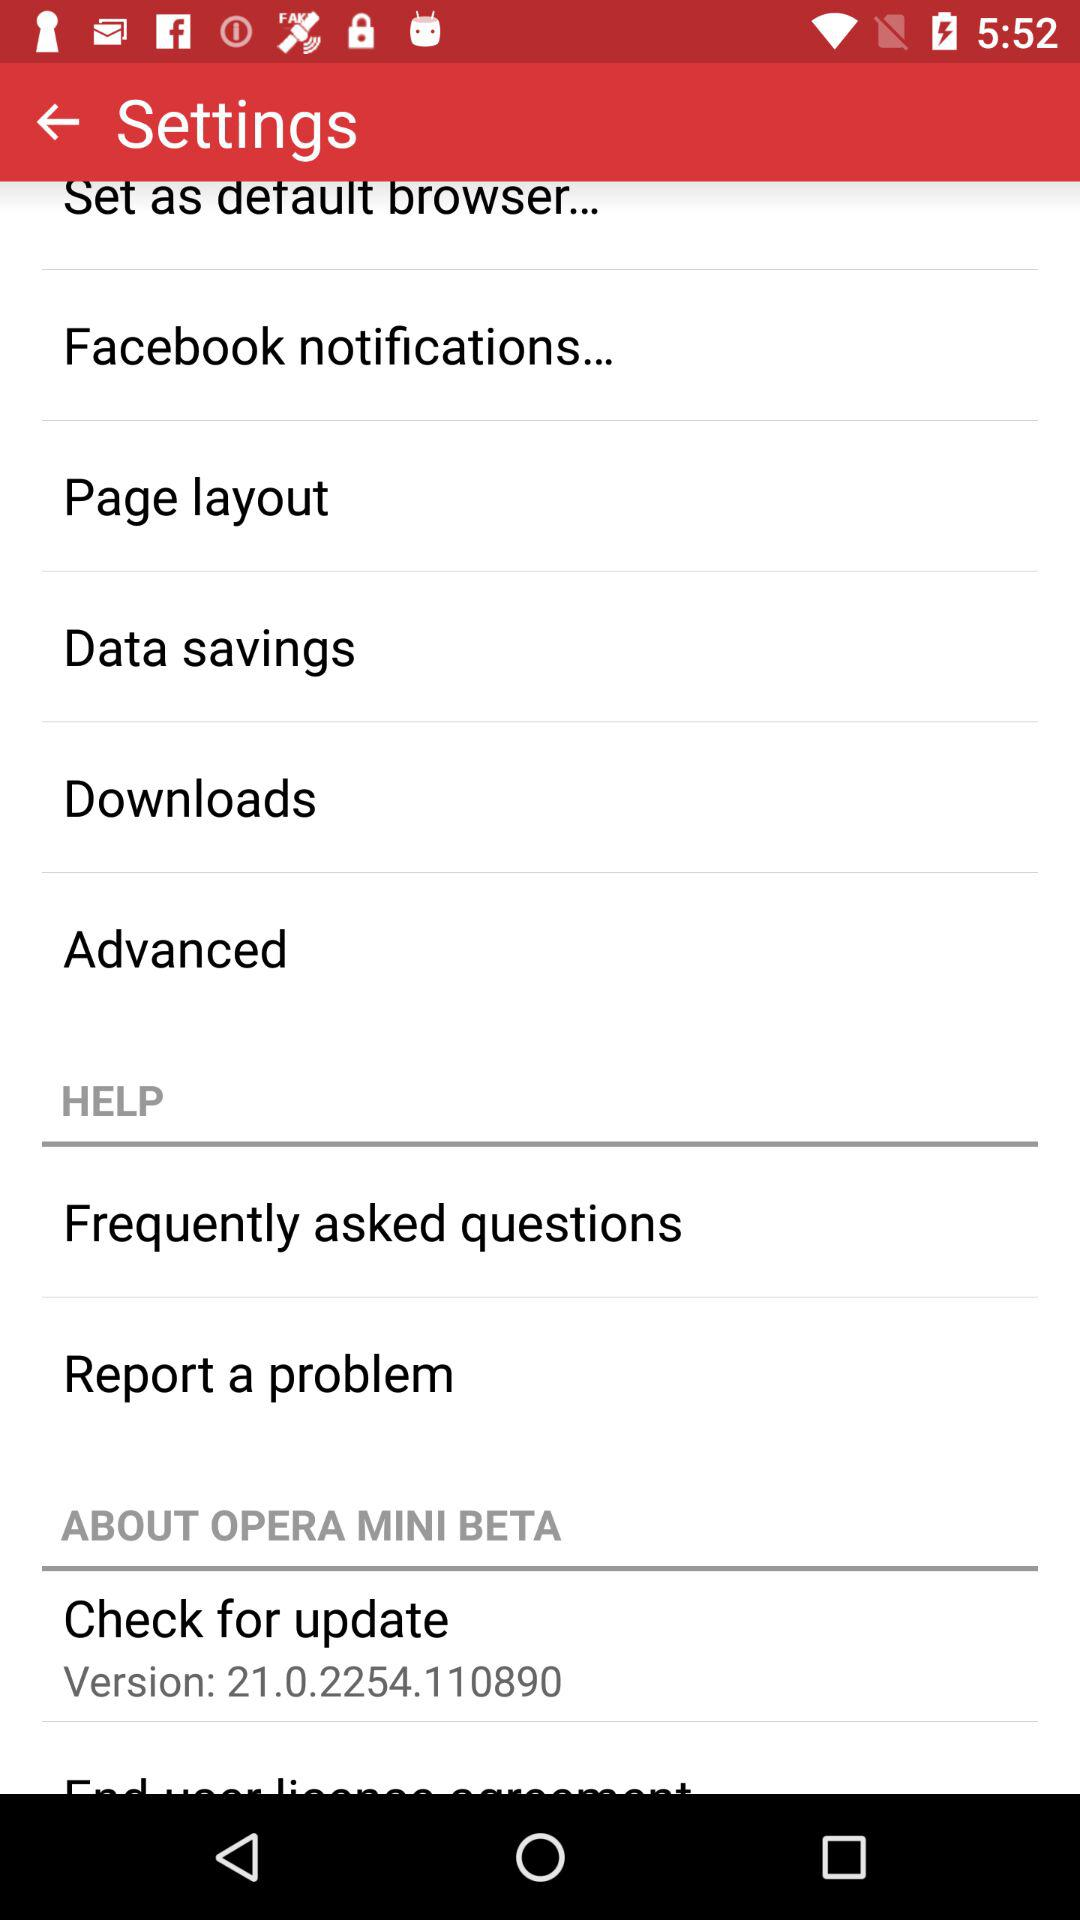Which questions are the most frequently asked?
When the provided information is insufficient, respond with <no answer>. <no answer> 